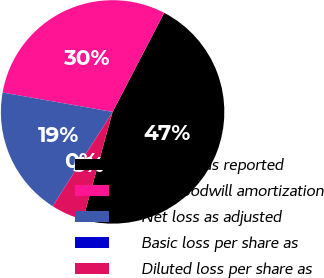Convert chart to OTSL. <chart><loc_0><loc_0><loc_500><loc_500><pie_chart><fcel>Net loss as reported<fcel>Add goodwill amortization<fcel>Net loss as adjusted<fcel>Basic loss per share as<fcel>Diluted loss per share as<nl><fcel>46.65%<fcel>29.86%<fcel>18.72%<fcel>0.06%<fcel>4.72%<nl></chart> 